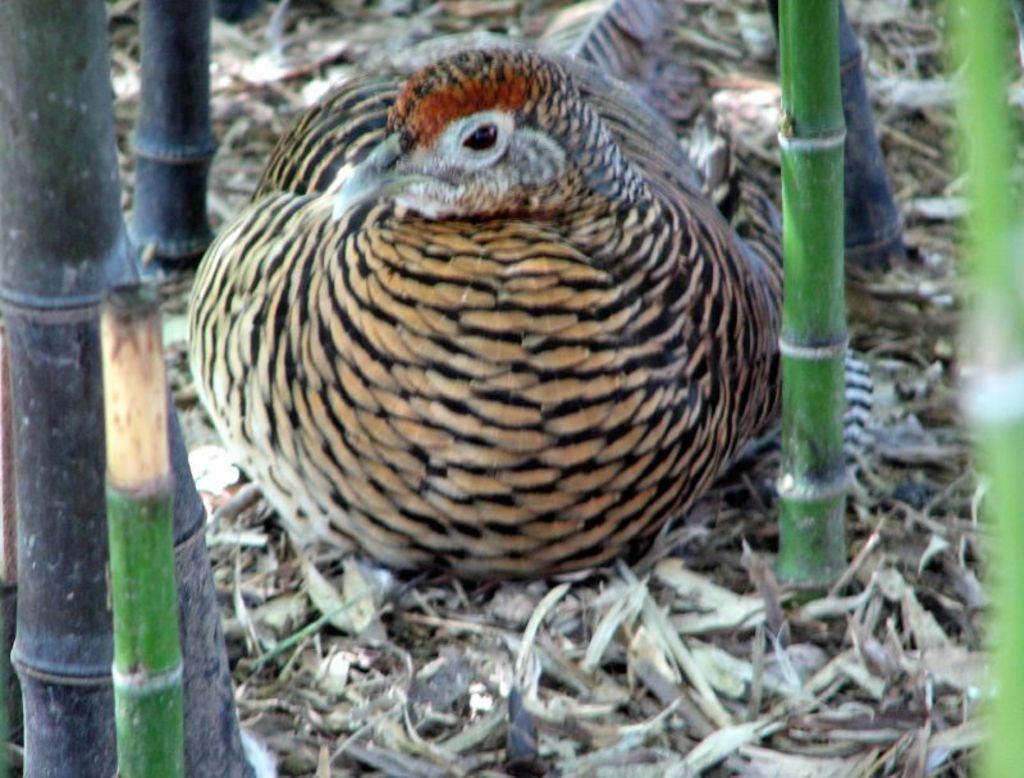What is the main subject in the center of the image? There is a bird in the center of the image. What can be seen at the bottom of the image? Shredded leaves are present at the bottom of the image. What type of sticks are visible in the image? There are bamboo sticks in the image. What type of shoe is the laborer wearing in the image? There is no laborer or shoe present in the image; it features a bird and bamboo sticks. What is inside the jar that is visible in the image? There is no jar present in the image. 